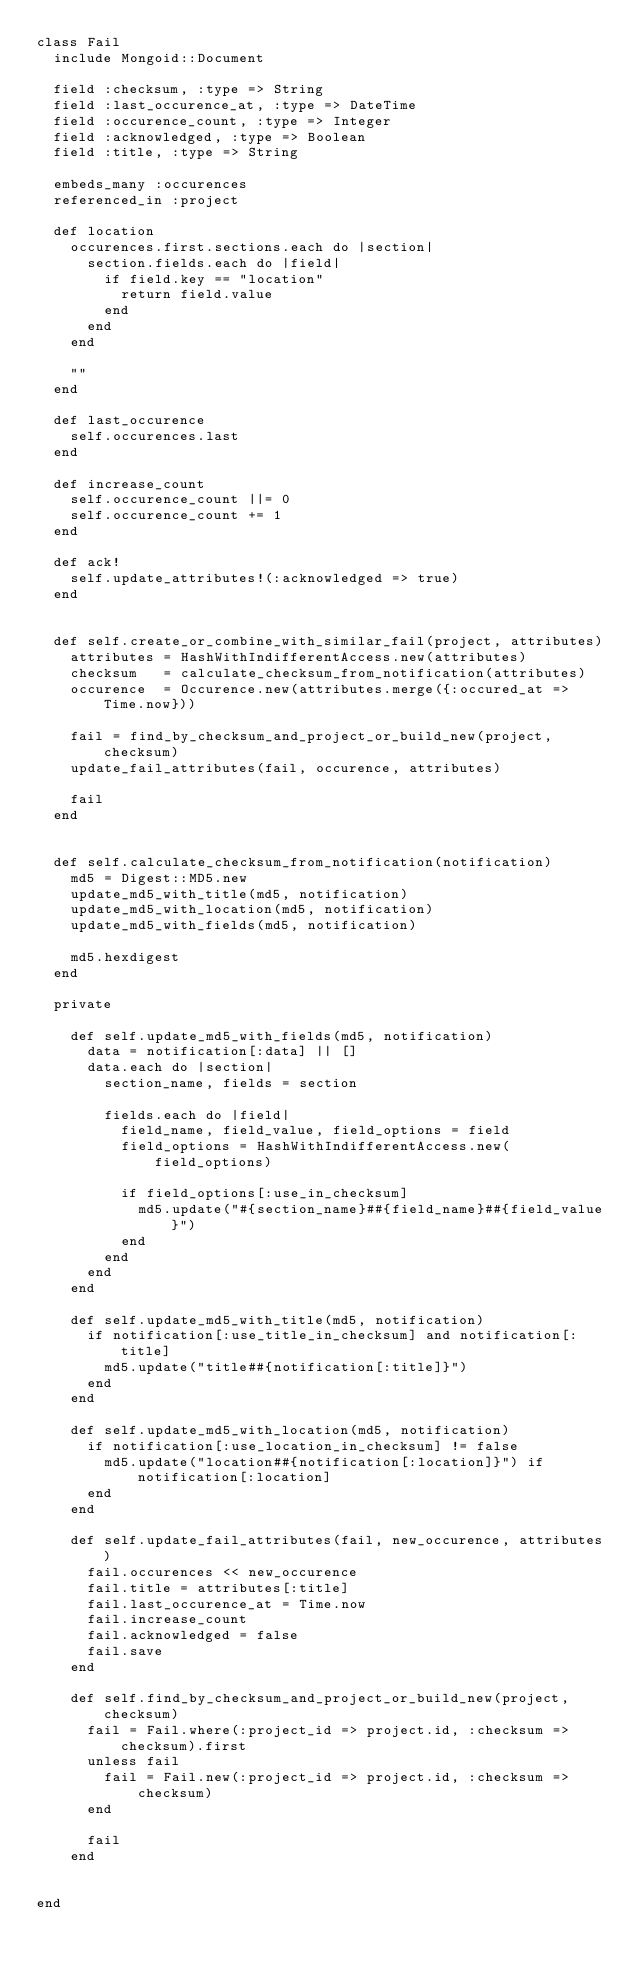Convert code to text. <code><loc_0><loc_0><loc_500><loc_500><_Ruby_>class Fail
  include Mongoid::Document
  
  field :checksum, :type => String
  field :last_occurence_at, :type => DateTime
  field :occurence_count, :type => Integer
  field :acknowledged, :type => Boolean
  field :title, :type => String
  
  embeds_many :occurences
  referenced_in :project

  def location
    occurences.first.sections.each do |section|
      section.fields.each do |field|
        if field.key == "location"
          return field.value
        end
      end
    end
    
    ""
  end
  
  def last_occurence
    self.occurences.last
  end
  
  def increase_count
    self.occurence_count ||= 0
    self.occurence_count += 1
  end
  
  def ack!
    self.update_attributes!(:acknowledged => true)
  end
 

  def self.create_or_combine_with_similar_fail(project, attributes)
    attributes = HashWithIndifferentAccess.new(attributes)
    checksum   = calculate_checksum_from_notification(attributes)
    occurence  = Occurence.new(attributes.merge({:occured_at => Time.now}))
    
    fail = find_by_checksum_and_project_or_build_new(project, checksum) 
    update_fail_attributes(fail, occurence, attributes)

    fail
  end
  

  def self.calculate_checksum_from_notification(notification)
    md5 = Digest::MD5.new
    update_md5_with_title(md5, notification)
    update_md5_with_location(md5, notification)
    update_md5_with_fields(md5, notification)

    md5.hexdigest
  end

  private

    def self.update_md5_with_fields(md5, notification)
      data = notification[:data] || []
      data.each do |section|
        section_name, fields = section

        fields.each do |field|
          field_name, field_value, field_options = field
          field_options = HashWithIndifferentAccess.new(field_options)

          if field_options[:use_in_checksum]
            md5.update("#{section_name}##{field_name}##{field_value}")
          end
        end
      end
    end

    def self.update_md5_with_title(md5, notification)
      if notification[:use_title_in_checksum] and notification[:title]
        md5.update("title##{notification[:title]}")
      end
    end

    def self.update_md5_with_location(md5, notification)
      if notification[:use_location_in_checksum] != false
        md5.update("location##{notification[:location]}") if notification[:location]
      end
    end

    def self.update_fail_attributes(fail, new_occurence, attributes)
      fail.occurences << new_occurence
      fail.title = attributes[:title]
      fail.last_occurence_at = Time.now 
      fail.increase_count
      fail.acknowledged = false
      fail.save
    end

    def self.find_by_checksum_and_project_or_build_new(project, checksum)
      fail = Fail.where(:project_id => project.id, :checksum => checksum).first
      unless fail
        fail = Fail.new(:project_id => project.id, :checksum => checksum)
      end

      fail
    end

  
end

</code> 